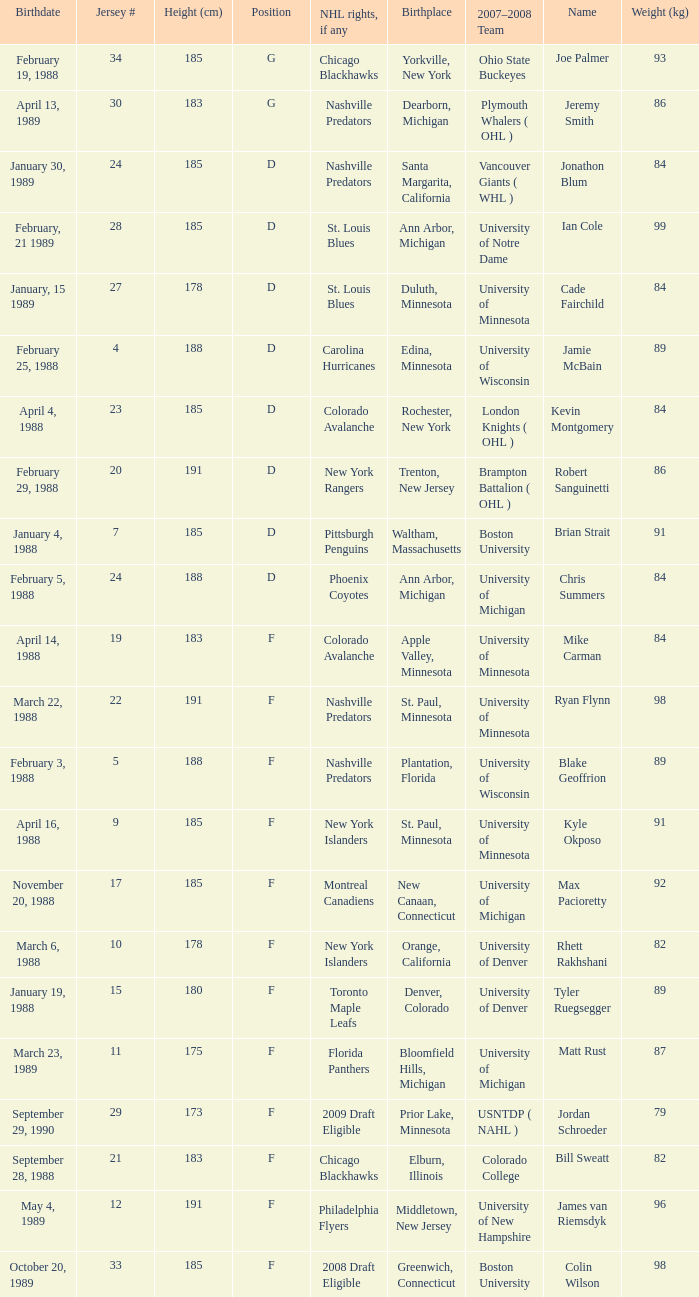Which Height (cm) has a Birthplace of bloomfield hills, michigan? 175.0. 